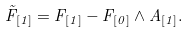Convert formula to latex. <formula><loc_0><loc_0><loc_500><loc_500>\tilde { F } _ { [ 1 ] } = F _ { [ 1 ] } - F _ { [ 0 ] } \wedge A _ { [ 1 ] } .</formula> 